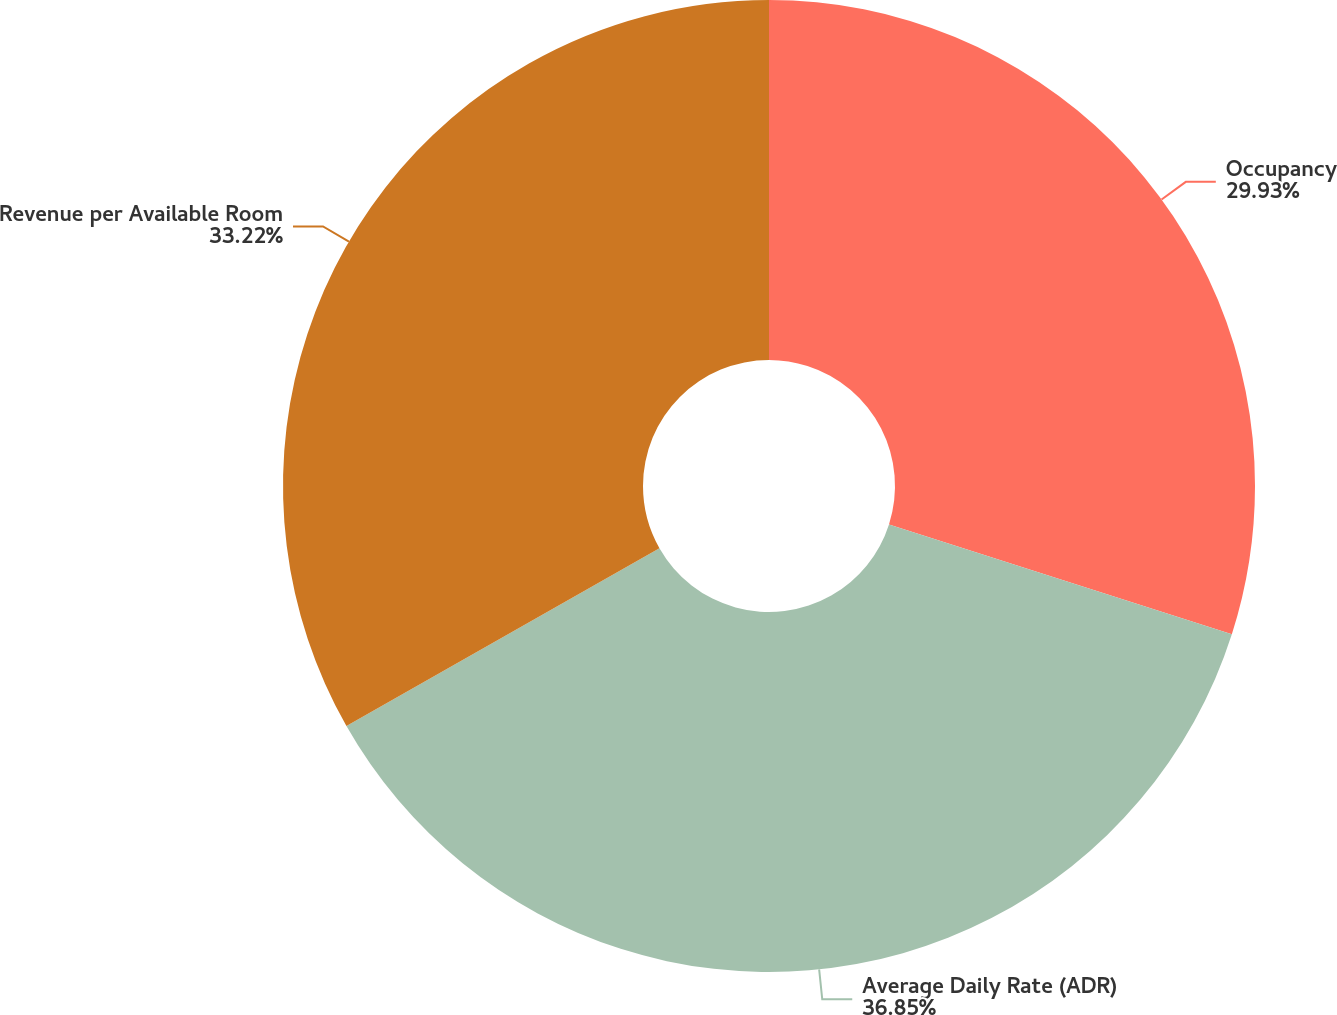Convert chart. <chart><loc_0><loc_0><loc_500><loc_500><pie_chart><fcel>Occupancy<fcel>Average Daily Rate (ADR)<fcel>Revenue per Available Room<nl><fcel>29.93%<fcel>36.84%<fcel>33.22%<nl></chart> 